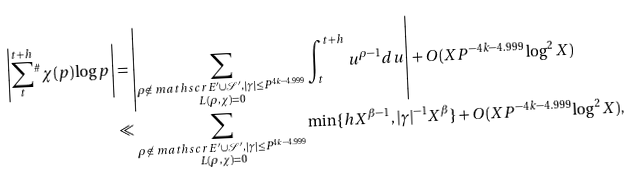Convert formula to latex. <formula><loc_0><loc_0><loc_500><loc_500>\left | \sum _ { t } ^ { t + h } { ^ { \# } } \chi ( p ) \log p \right | & = \left | \sum _ { \substack { \rho \not \in \ m a t h s c r { E } ^ { \prime } \cup \mathcal { S } ^ { \prime } , | \gamma | \leq P ^ { 4 k - 4 . 9 9 9 } \\ L ( \rho , \chi ) = 0 } } \int _ { t } ^ { t + h } u ^ { \rho - 1 } d u \right | + O ( X P ^ { - 4 k - 4 . 9 9 9 } \log ^ { 2 } X ) \\ & \ll \sum _ { \substack { \rho \not \in \ m a t h s c r { E } ^ { \prime } \cup \mathcal { S } ^ { \prime } , | \gamma | \leq P ^ { 4 k - 4 . 9 9 9 } \\ L ( \rho , \chi ) = 0 } } \min \{ h X ^ { \beta - 1 } , | \gamma | ^ { - 1 } X ^ { \beta } \} + O ( X P ^ { - 4 k - 4 . 9 9 9 } \log ^ { 2 } X ) ,</formula> 